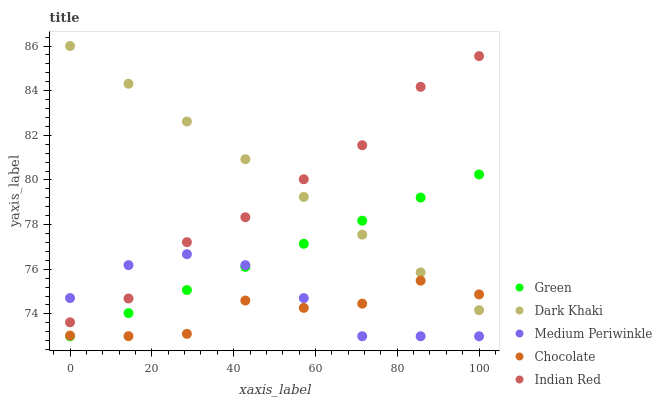Does Chocolate have the minimum area under the curve?
Answer yes or no. Yes. Does Dark Khaki have the maximum area under the curve?
Answer yes or no. Yes. Does Medium Periwinkle have the minimum area under the curve?
Answer yes or no. No. Does Medium Periwinkle have the maximum area under the curve?
Answer yes or no. No. Is Green the smoothest?
Answer yes or no. Yes. Is Chocolate the roughest?
Answer yes or no. Yes. Is Medium Periwinkle the smoothest?
Answer yes or no. No. Is Medium Periwinkle the roughest?
Answer yes or no. No. Does Medium Periwinkle have the lowest value?
Answer yes or no. Yes. Does Indian Red have the lowest value?
Answer yes or no. No. Does Dark Khaki have the highest value?
Answer yes or no. Yes. Does Medium Periwinkle have the highest value?
Answer yes or no. No. Is Medium Periwinkle less than Dark Khaki?
Answer yes or no. Yes. Is Indian Red greater than Green?
Answer yes or no. Yes. Does Chocolate intersect Green?
Answer yes or no. Yes. Is Chocolate less than Green?
Answer yes or no. No. Is Chocolate greater than Green?
Answer yes or no. No. Does Medium Periwinkle intersect Dark Khaki?
Answer yes or no. No. 